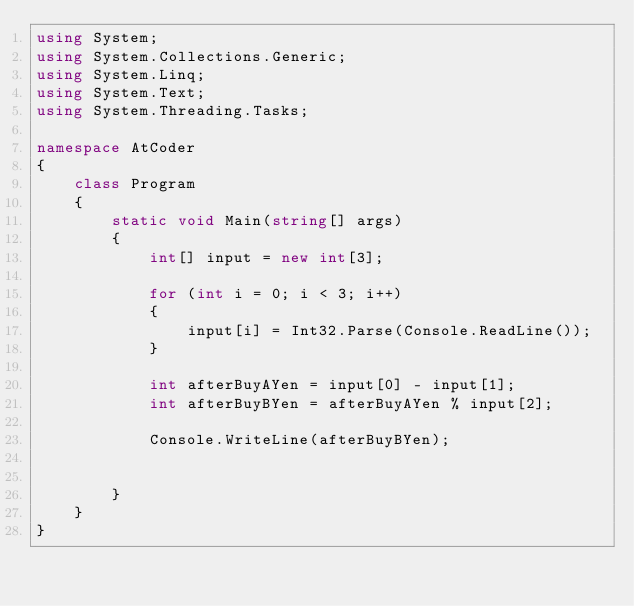<code> <loc_0><loc_0><loc_500><loc_500><_C#_>using System;
using System.Collections.Generic;
using System.Linq;
using System.Text;
using System.Threading.Tasks;

namespace AtCoder
{
    class Program
    {
        static void Main(string[] args)
        {
            int[] input = new int[3];

            for (int i = 0; i < 3; i++)
            {
                input[i] = Int32.Parse(Console.ReadLine());
            }

            int afterBuyAYen = input[0] - input[1];
            int afterBuyBYen = afterBuyAYen % input[2];

            Console.WriteLine(afterBuyBYen);


        }
    }
}
</code> 